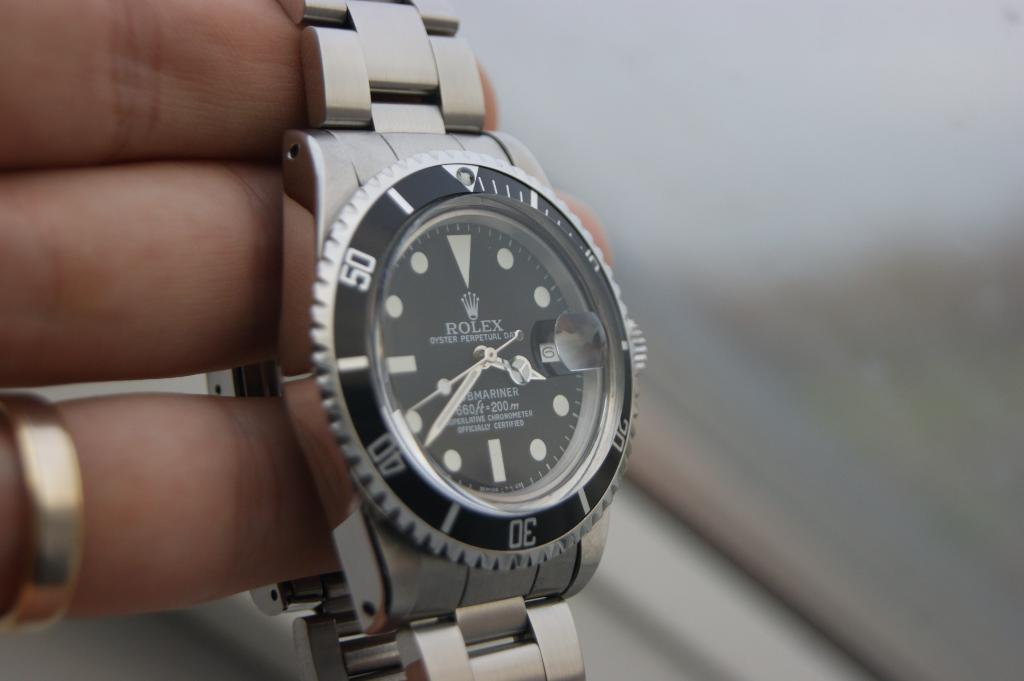<image>
Present a compact description of the photo's key features. A person is holding a ROLEX watch on their fingers. 